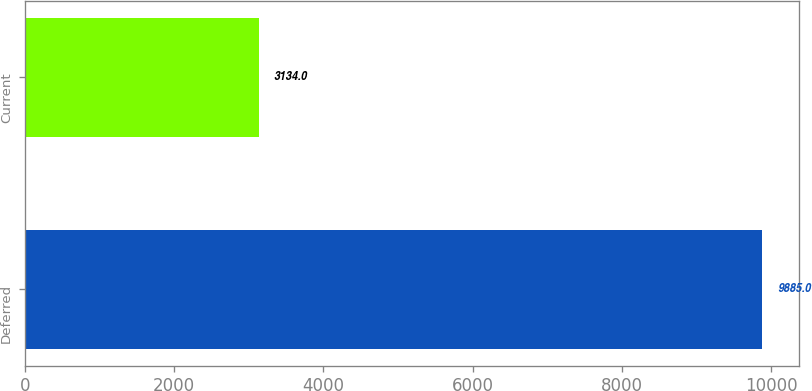Convert chart to OTSL. <chart><loc_0><loc_0><loc_500><loc_500><bar_chart><fcel>Deferred<fcel>Current<nl><fcel>9885<fcel>3134<nl></chart> 